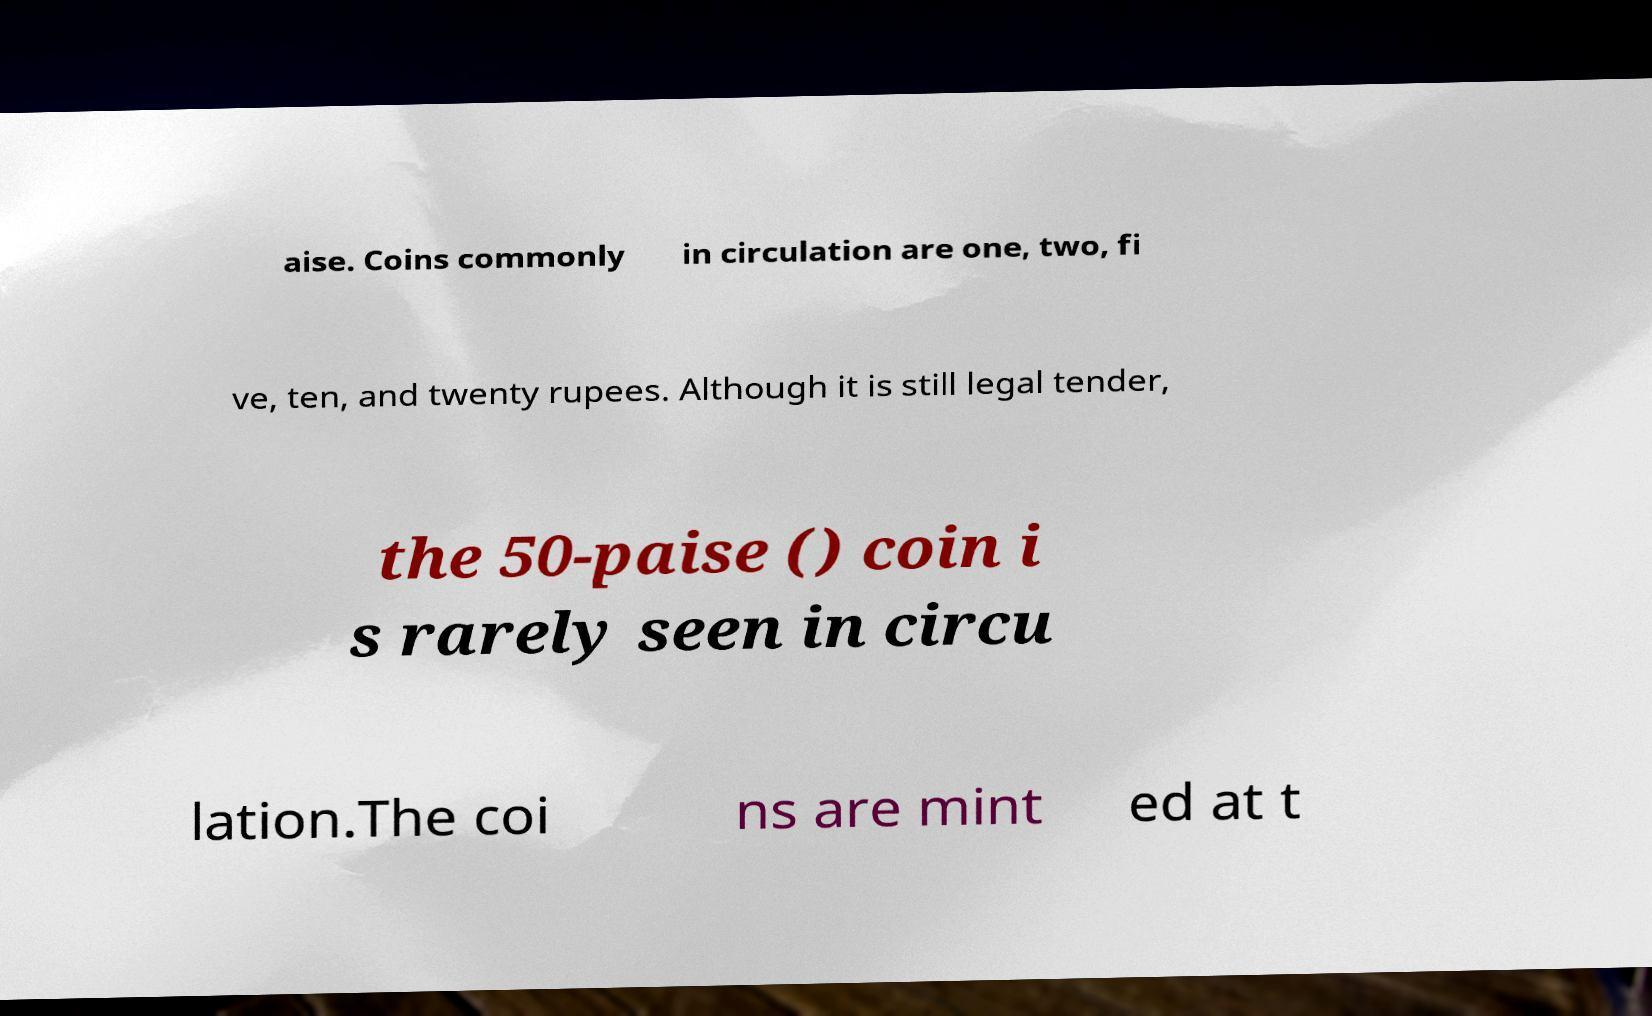Could you assist in decoding the text presented in this image and type it out clearly? aise. Coins commonly in circulation are one, two, fi ve, ten, and twenty rupees. Although it is still legal tender, the 50-paise () coin i s rarely seen in circu lation.The coi ns are mint ed at t 